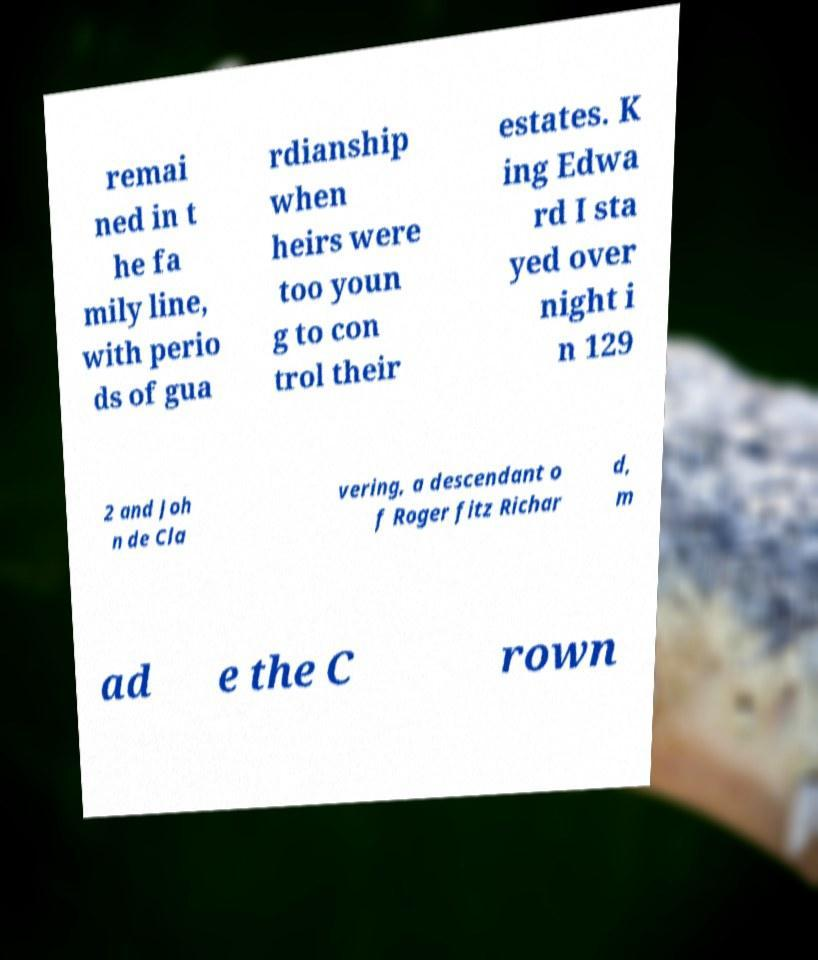Can you accurately transcribe the text from the provided image for me? remai ned in t he fa mily line, with perio ds of gua rdianship when heirs were too youn g to con trol their estates. K ing Edwa rd I sta yed over night i n 129 2 and Joh n de Cla vering, a descendant o f Roger fitz Richar d, m ad e the C rown 